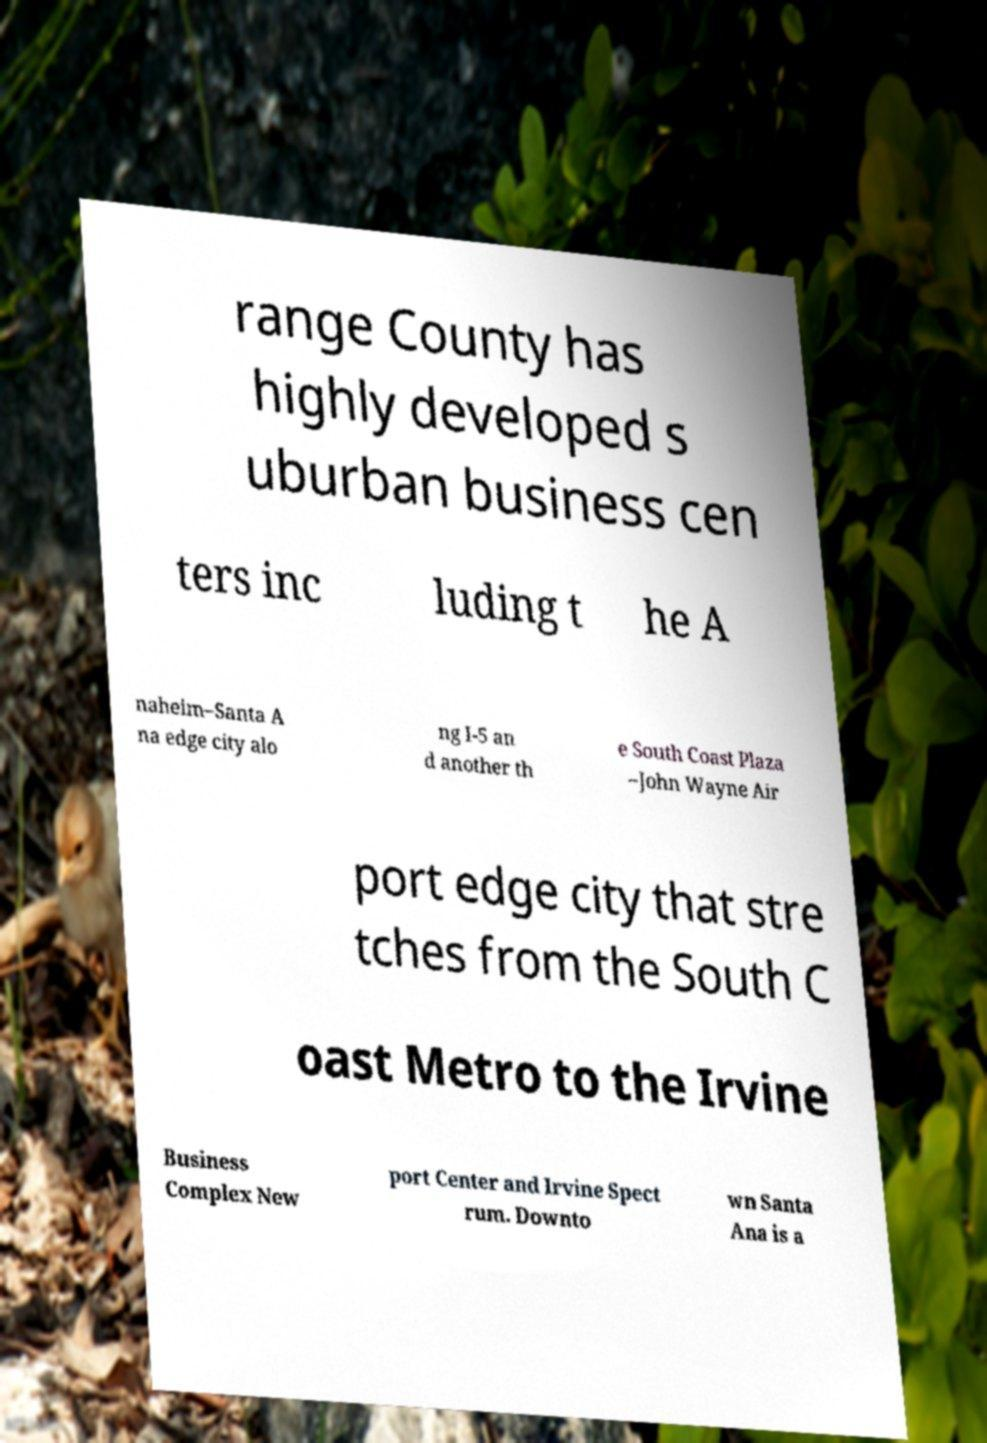What messages or text are displayed in this image? I need them in a readable, typed format. range County has highly developed s uburban business cen ters inc luding t he A naheim–Santa A na edge city alo ng I-5 an d another th e South Coast Plaza –John Wayne Air port edge city that stre tches from the South C oast Metro to the Irvine Business Complex New port Center and Irvine Spect rum. Downto wn Santa Ana is a 